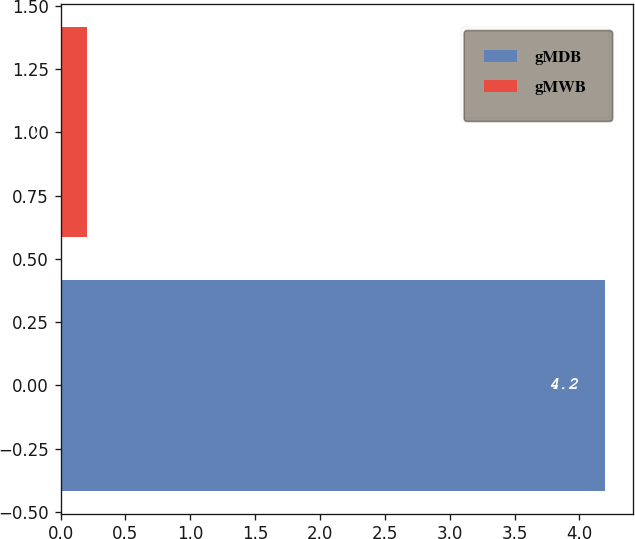Convert chart. <chart><loc_0><loc_0><loc_500><loc_500><bar_chart><fcel>gMDB<fcel>gMWB<nl><fcel>4.2<fcel>0.2<nl></chart> 